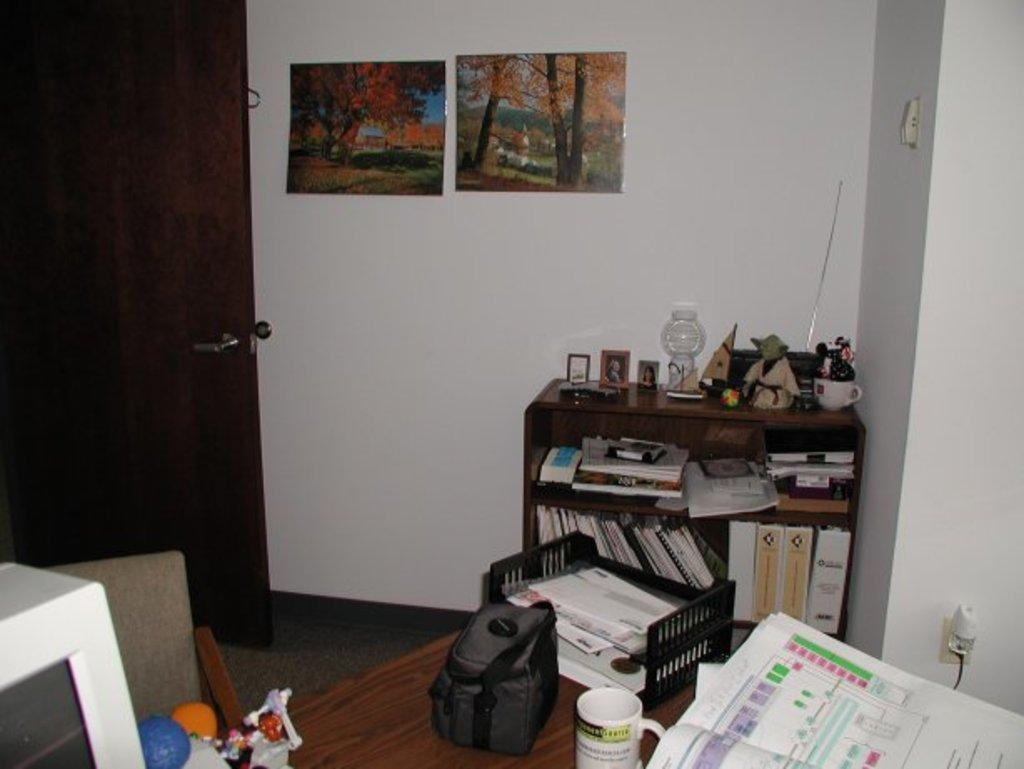Can you describe this image briefly? In the image we can see there is a table on which there is a backpack, coffee mug and a monitor kept and there are books and other decorative items on the table. 